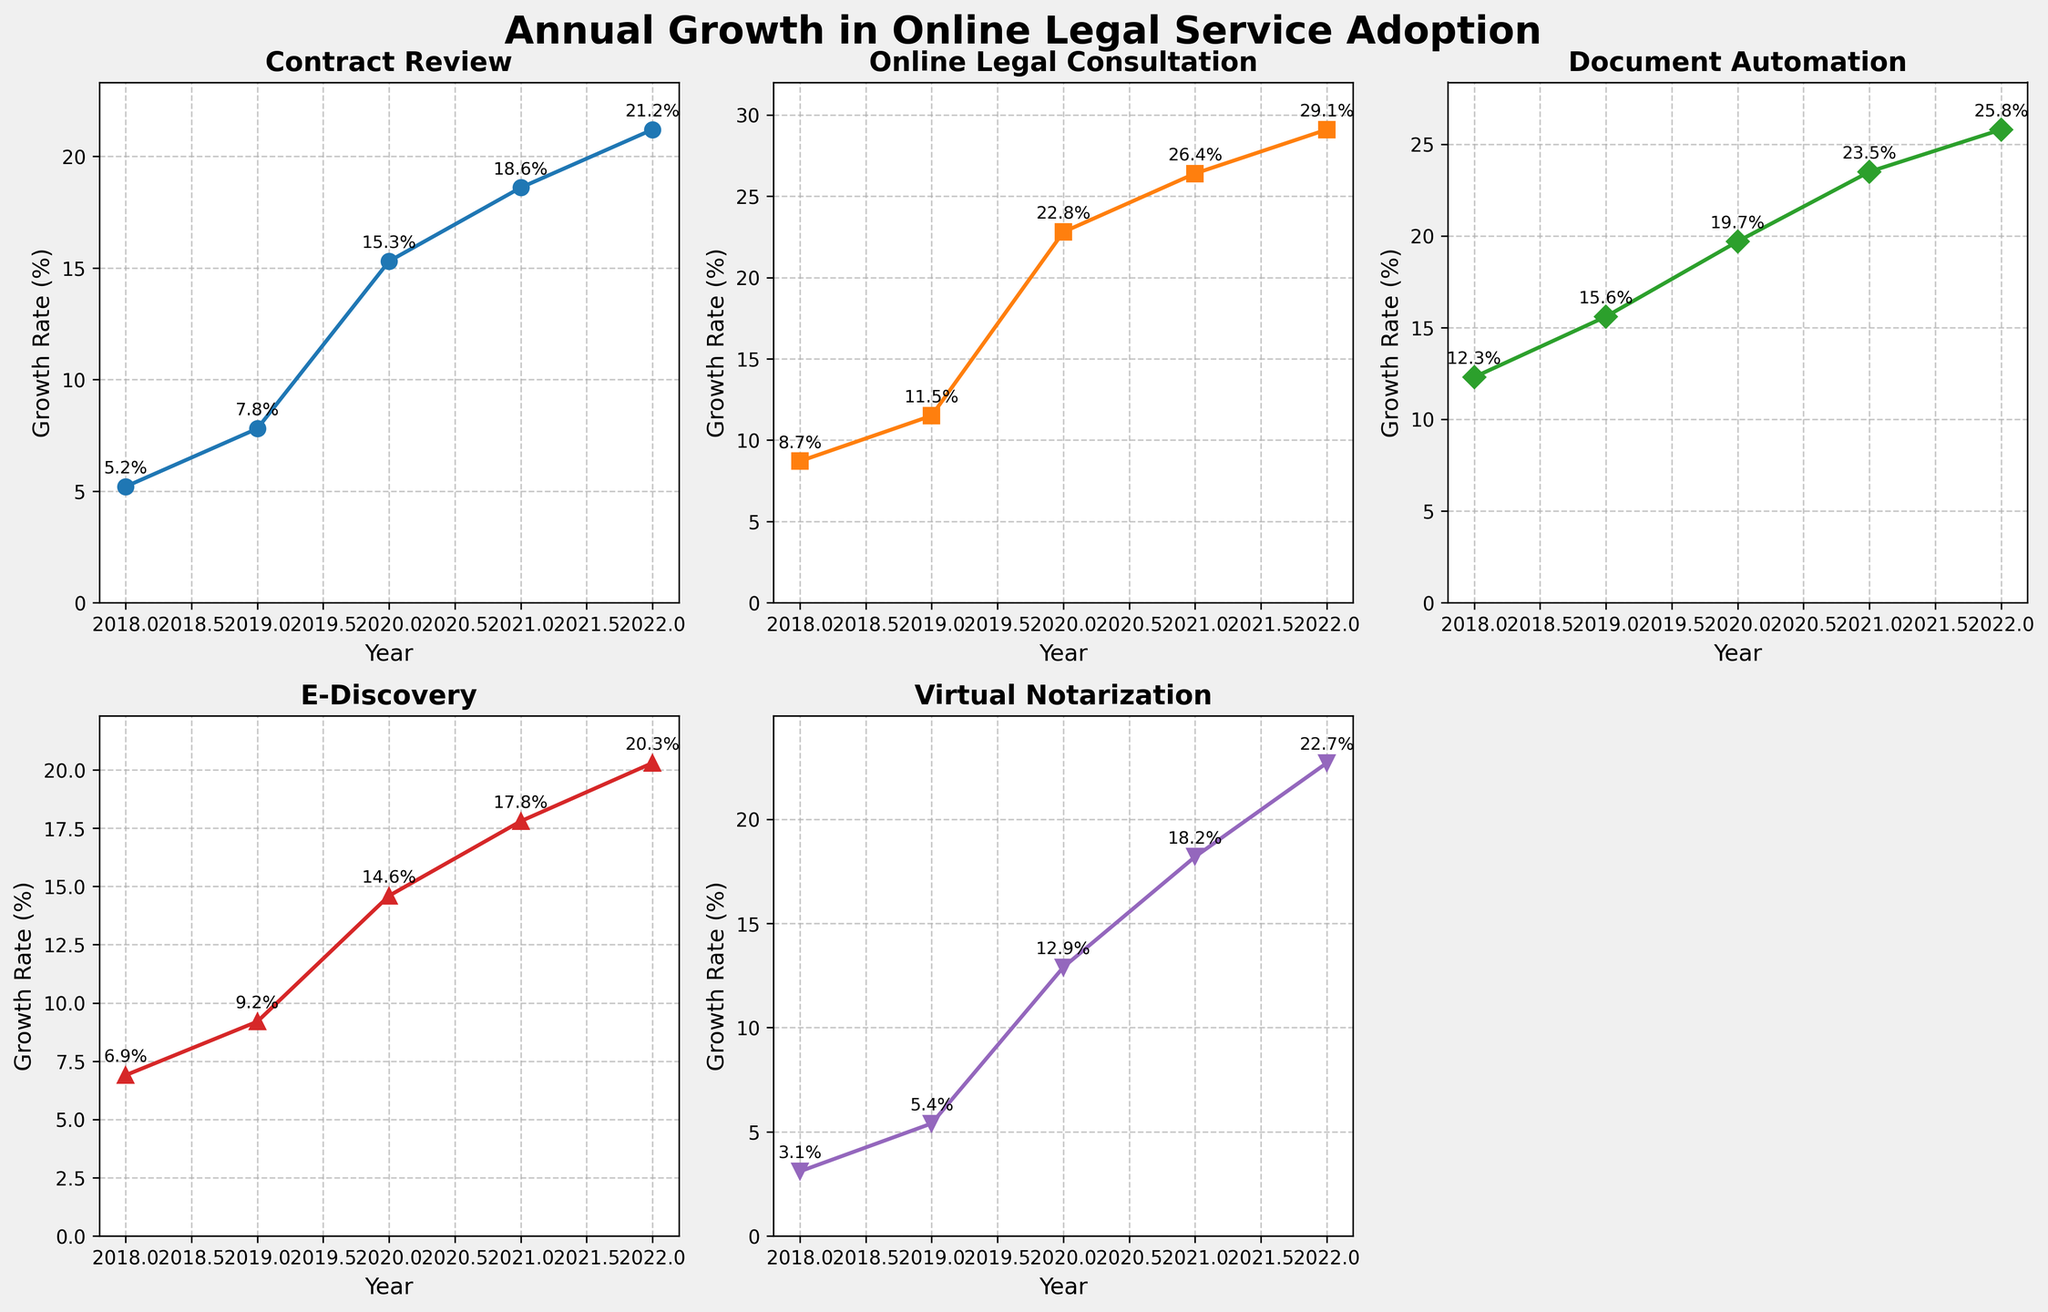What is the title of the overall plot? The overall plot title is displayed at the top of the figure and says "Annual Growth in Online Legal Service Adoption".
Answer: Annual Growth in Online Legal Service Adoption How many subplots are there in the figure? The figure is divided into a 2x3 grid, resulting in a total of 6 subplots, but one subplot is empty. So, there are 5 subplots showcasing different services.
Answer: 5 Which service had the highest growth rate in 2021? By looking at the 2021 data point for each service and comparing them, we see that Virtual Notarization peaked at 18.2%.
Answer: Virtual Notarization How did the growth rate of E-Discovery change from 2019 to 2022? We need to look at the E-Discovery subplot and note the values: 2019: 9.2%, 2022: 20.3%. The change is 20.3% - 9.2% = 11.1%.
Answer: Increased by 11.1 percentage points Which year showed the most significant increase in growth rate for Online Legal Consultation? The most significant increase can be identified by looking at the sharpest slope for the Online Legal Consultation line. The growth from 2019 (11.5%) to 2020 (22.8%) is the most notable.
Answer: 2020 Between Contract Review and Document Automation, which had a higher growth rate in 2020? Comparing the 2020 data points for both services: Contract Review (15.3%) vs. Document Automation (19.7%). Document Automation had a higher growth rate.
Answer: Document Automation What is the average growth rate for Online Legal Consultation over the years displayed? Sum the growth rates over the years and divide by the number of years: (8.7 + 11.5 + 22.8 + 26.4 + 29.1) / 5. This equals 19.7%.
Answer: 19.7% Compare the growth rates of Virtual Notarization and Online Legal Consultation in 2022. Which one is higher and by how much? In 2022, Virtual Notarization had a growth rate of 22.7%, while Online Legal Consultation was at 29.1%. The difference is 29.1% - 22.7% = 6.4%.
Answer: Online Legal Consultation by 6.4 percentage points Which service had the most consistent year-over-year growth from 2018 to 2022? The most consistent growth can be identified by observing which line appears smoothest without sharp changes. Contract Review shows relatively uniform growth throughout.
Answer: Contract Review What was the growth trend for Document Automation between 2019 and 2021? Document Automation had a growth rate of 15.6% in 2019, which increased to 19.7% in 2020, and then to 23.5% in 2021. The trend shows consistent yearly increases: 15.6% -> 19.7% -> 23.5%.
Answer: Consistently increasing 